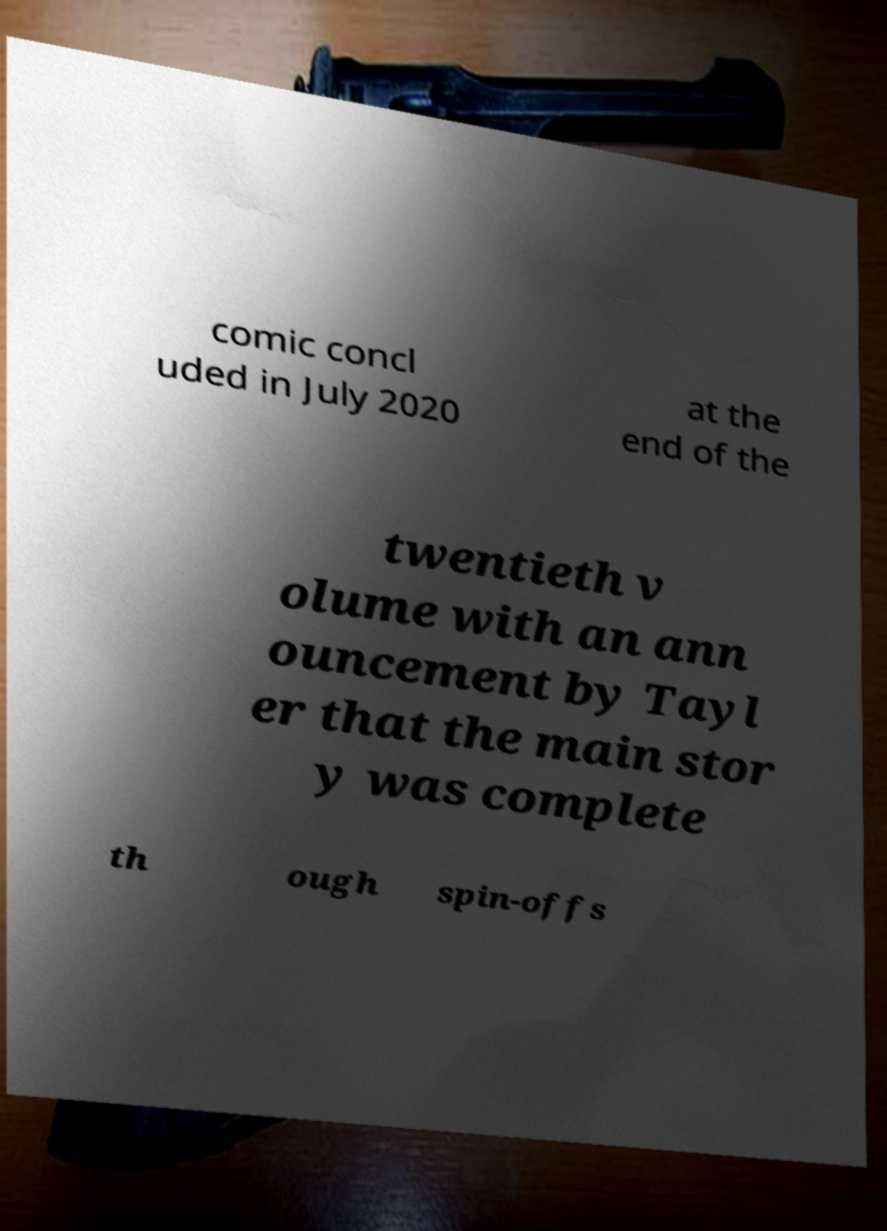There's text embedded in this image that I need extracted. Can you transcribe it verbatim? comic concl uded in July 2020 at the end of the twentieth v olume with an ann ouncement by Tayl er that the main stor y was complete th ough spin-offs 